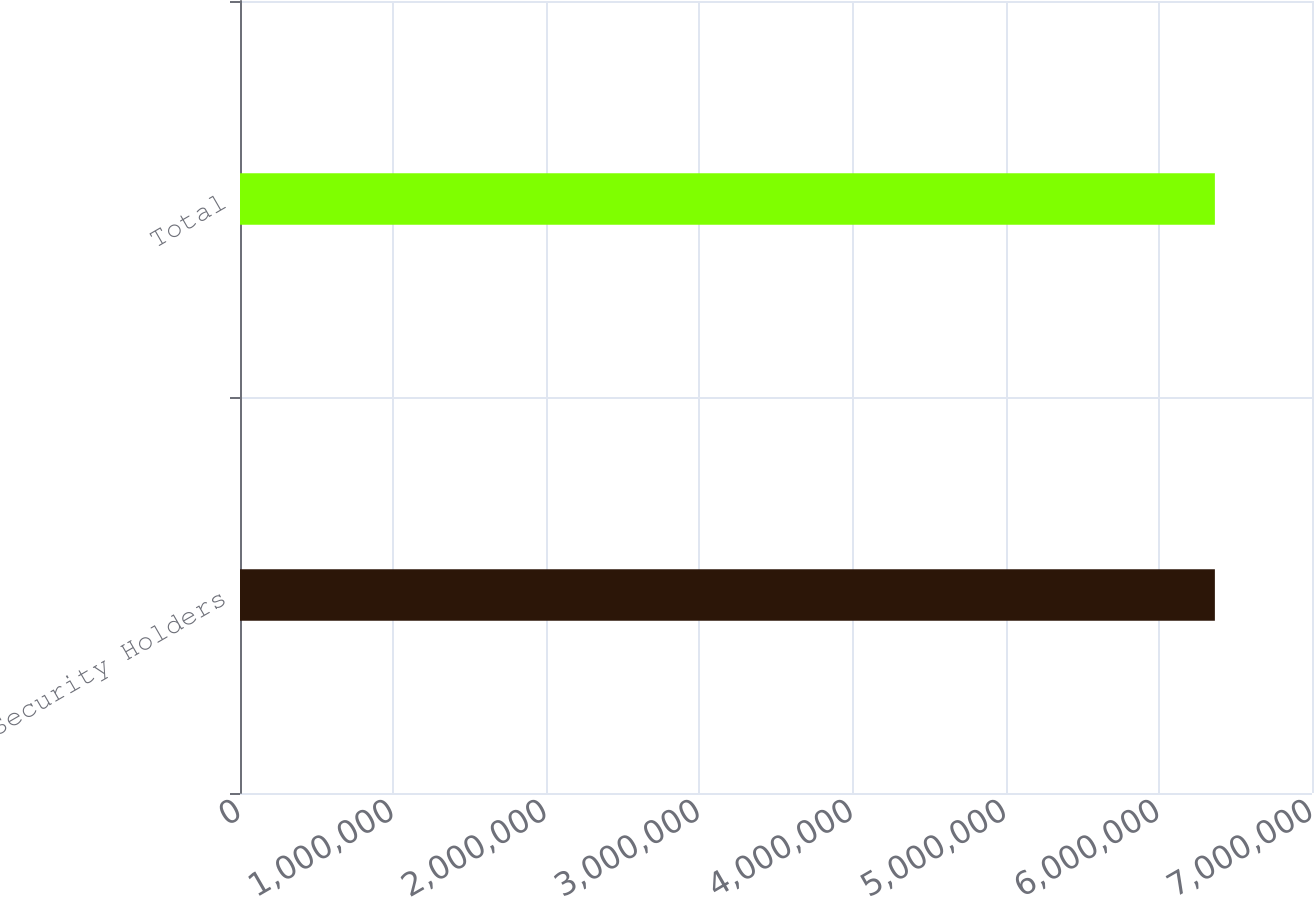Convert chart to OTSL. <chart><loc_0><loc_0><loc_500><loc_500><bar_chart><fcel>Security Holders<fcel>Total<nl><fcel>6.36582e+06<fcel>6.36582e+06<nl></chart> 